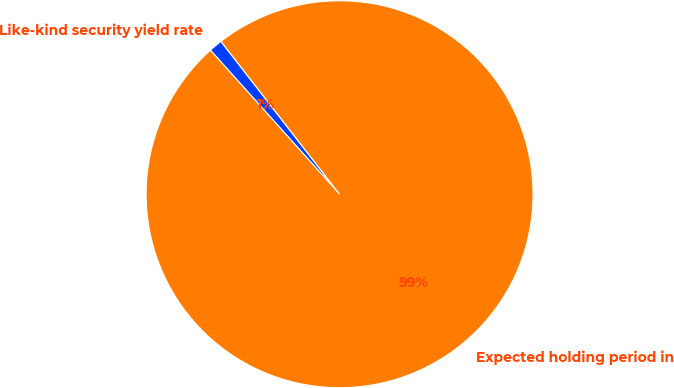Convert chart. <chart><loc_0><loc_0><loc_500><loc_500><pie_chart><fcel>Like-kind security yield rate<fcel>Expected holding period in<nl><fcel>1.13%<fcel>98.87%<nl></chart> 